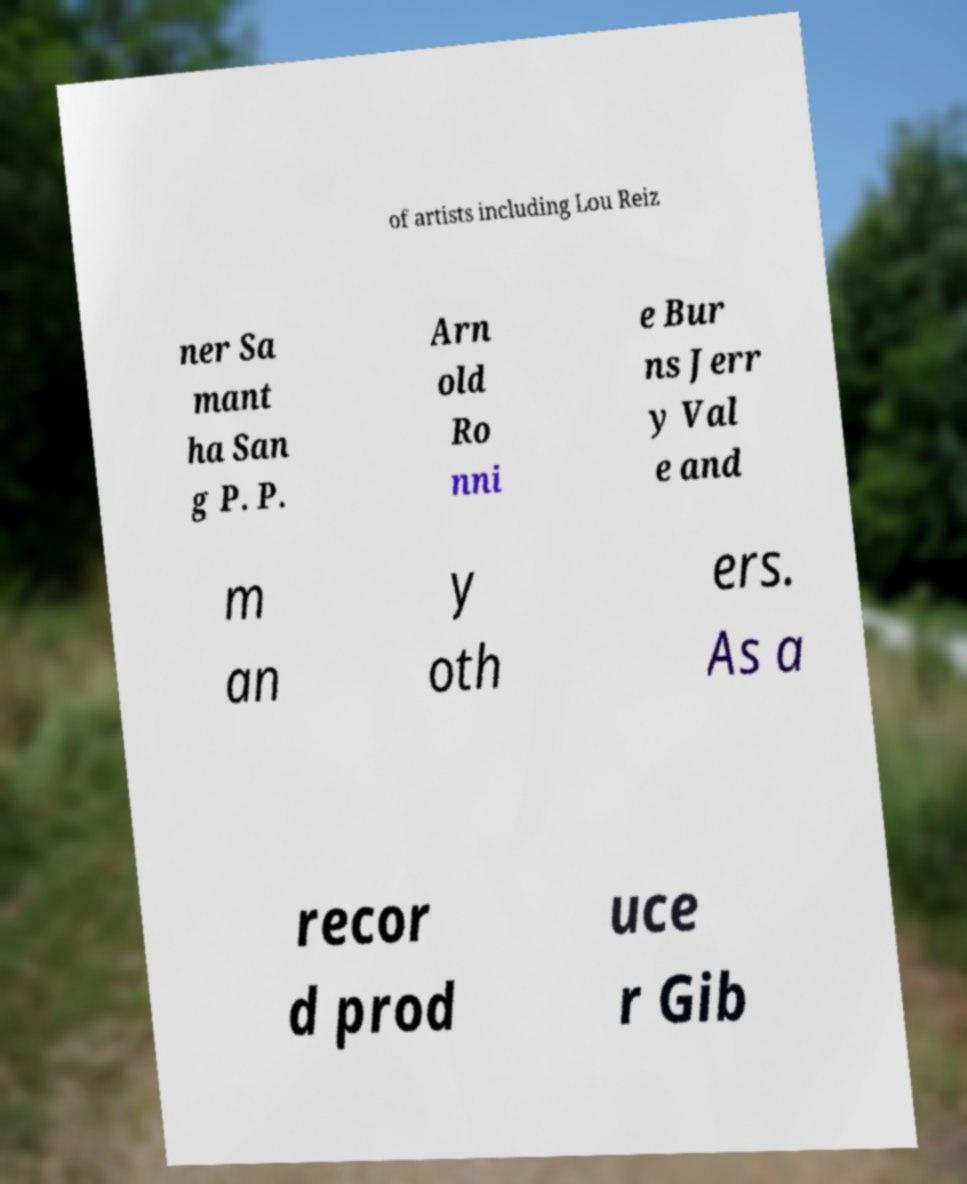Can you read and provide the text displayed in the image?This photo seems to have some interesting text. Can you extract and type it out for me? of artists including Lou Reiz ner Sa mant ha San g P. P. Arn old Ro nni e Bur ns Jerr y Val e and m an y oth ers. As a recor d prod uce r Gib 